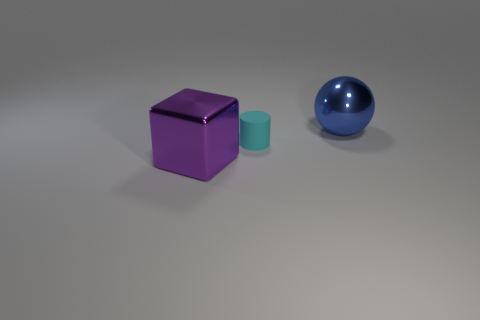Add 3 small blue rubber things. How many objects exist? 6 Add 2 shiny spheres. How many shiny spheres exist? 3 Subtract 0 blue cylinders. How many objects are left? 3 Subtract all cylinders. How many objects are left? 2 Subtract all brown blocks. Subtract all red cylinders. How many blocks are left? 1 Subtract all big purple metallic blocks. Subtract all purple blocks. How many objects are left? 1 Add 2 tiny matte things. How many tiny matte things are left? 3 